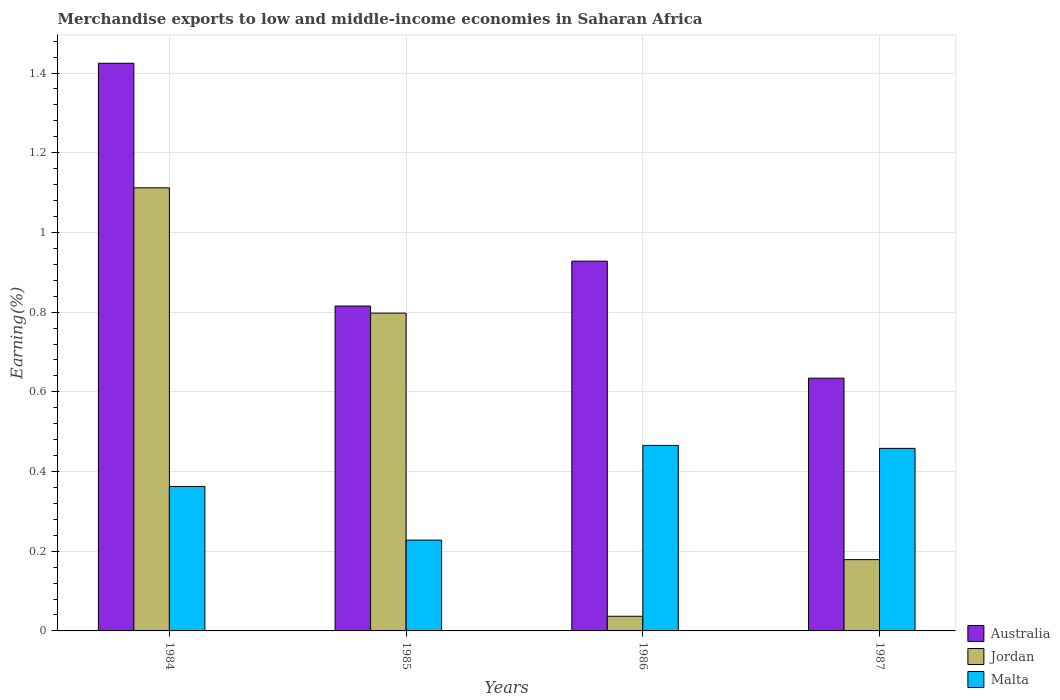How many different coloured bars are there?
Give a very brief answer. 3. How many groups of bars are there?
Your answer should be compact. 4. Are the number of bars per tick equal to the number of legend labels?
Ensure brevity in your answer.  Yes. How many bars are there on the 1st tick from the right?
Ensure brevity in your answer.  3. In how many cases, is the number of bars for a given year not equal to the number of legend labels?
Your response must be concise. 0. What is the percentage of amount earned from merchandise exports in Jordan in 1987?
Your answer should be compact. 0.18. Across all years, what is the maximum percentage of amount earned from merchandise exports in Malta?
Provide a succinct answer. 0.47. Across all years, what is the minimum percentage of amount earned from merchandise exports in Australia?
Your answer should be compact. 0.63. In which year was the percentage of amount earned from merchandise exports in Malta minimum?
Give a very brief answer. 1985. What is the total percentage of amount earned from merchandise exports in Australia in the graph?
Your response must be concise. 3.8. What is the difference between the percentage of amount earned from merchandise exports in Australia in 1986 and that in 1987?
Ensure brevity in your answer.  0.29. What is the difference between the percentage of amount earned from merchandise exports in Australia in 1986 and the percentage of amount earned from merchandise exports in Jordan in 1984?
Your answer should be compact. -0.18. What is the average percentage of amount earned from merchandise exports in Malta per year?
Your answer should be very brief. 0.38. In the year 1986, what is the difference between the percentage of amount earned from merchandise exports in Malta and percentage of amount earned from merchandise exports in Australia?
Provide a succinct answer. -0.46. What is the ratio of the percentage of amount earned from merchandise exports in Malta in 1984 to that in 1987?
Offer a terse response. 0.79. What is the difference between the highest and the second highest percentage of amount earned from merchandise exports in Malta?
Give a very brief answer. 0.01. What is the difference between the highest and the lowest percentage of amount earned from merchandise exports in Jordan?
Provide a succinct answer. 1.08. What does the 2nd bar from the right in 1987 represents?
Give a very brief answer. Jordan. What is the difference between two consecutive major ticks on the Y-axis?
Your response must be concise. 0.2. Does the graph contain any zero values?
Provide a succinct answer. No. Does the graph contain grids?
Your response must be concise. Yes. What is the title of the graph?
Your answer should be very brief. Merchandise exports to low and middle-income economies in Saharan Africa. What is the label or title of the X-axis?
Ensure brevity in your answer.  Years. What is the label or title of the Y-axis?
Offer a very short reply. Earning(%). What is the Earning(%) of Australia in 1984?
Offer a very short reply. 1.42. What is the Earning(%) in Jordan in 1984?
Provide a succinct answer. 1.11. What is the Earning(%) of Malta in 1984?
Ensure brevity in your answer.  0.36. What is the Earning(%) in Australia in 1985?
Your response must be concise. 0.82. What is the Earning(%) of Jordan in 1985?
Keep it short and to the point. 0.8. What is the Earning(%) of Malta in 1985?
Your answer should be very brief. 0.23. What is the Earning(%) in Australia in 1986?
Your response must be concise. 0.93. What is the Earning(%) in Jordan in 1986?
Your response must be concise. 0.04. What is the Earning(%) of Malta in 1986?
Your response must be concise. 0.47. What is the Earning(%) of Australia in 1987?
Offer a terse response. 0.63. What is the Earning(%) of Jordan in 1987?
Your answer should be compact. 0.18. What is the Earning(%) of Malta in 1987?
Give a very brief answer. 0.46. Across all years, what is the maximum Earning(%) of Australia?
Your answer should be very brief. 1.42. Across all years, what is the maximum Earning(%) of Jordan?
Provide a short and direct response. 1.11. Across all years, what is the maximum Earning(%) of Malta?
Give a very brief answer. 0.47. Across all years, what is the minimum Earning(%) of Australia?
Ensure brevity in your answer.  0.63. Across all years, what is the minimum Earning(%) of Jordan?
Your answer should be compact. 0.04. Across all years, what is the minimum Earning(%) of Malta?
Give a very brief answer. 0.23. What is the total Earning(%) in Australia in the graph?
Offer a terse response. 3.8. What is the total Earning(%) of Jordan in the graph?
Make the answer very short. 2.13. What is the total Earning(%) of Malta in the graph?
Make the answer very short. 1.51. What is the difference between the Earning(%) in Australia in 1984 and that in 1985?
Your response must be concise. 0.61. What is the difference between the Earning(%) of Jordan in 1984 and that in 1985?
Your answer should be compact. 0.31. What is the difference between the Earning(%) in Malta in 1984 and that in 1985?
Your answer should be compact. 0.13. What is the difference between the Earning(%) of Australia in 1984 and that in 1986?
Your answer should be compact. 0.5. What is the difference between the Earning(%) of Jordan in 1984 and that in 1986?
Your answer should be compact. 1.08. What is the difference between the Earning(%) of Malta in 1984 and that in 1986?
Give a very brief answer. -0.1. What is the difference between the Earning(%) in Australia in 1984 and that in 1987?
Your answer should be compact. 0.79. What is the difference between the Earning(%) of Jordan in 1984 and that in 1987?
Provide a short and direct response. 0.93. What is the difference between the Earning(%) in Malta in 1984 and that in 1987?
Keep it short and to the point. -0.1. What is the difference between the Earning(%) of Australia in 1985 and that in 1986?
Your answer should be compact. -0.11. What is the difference between the Earning(%) of Jordan in 1985 and that in 1986?
Make the answer very short. 0.76. What is the difference between the Earning(%) of Malta in 1985 and that in 1986?
Make the answer very short. -0.24. What is the difference between the Earning(%) of Australia in 1985 and that in 1987?
Your response must be concise. 0.18. What is the difference between the Earning(%) of Jordan in 1985 and that in 1987?
Give a very brief answer. 0.62. What is the difference between the Earning(%) in Malta in 1985 and that in 1987?
Ensure brevity in your answer.  -0.23. What is the difference between the Earning(%) of Australia in 1986 and that in 1987?
Provide a succinct answer. 0.29. What is the difference between the Earning(%) of Jordan in 1986 and that in 1987?
Your answer should be compact. -0.14. What is the difference between the Earning(%) in Malta in 1986 and that in 1987?
Your answer should be very brief. 0.01. What is the difference between the Earning(%) of Australia in 1984 and the Earning(%) of Jordan in 1985?
Your answer should be very brief. 0.63. What is the difference between the Earning(%) in Australia in 1984 and the Earning(%) in Malta in 1985?
Your answer should be very brief. 1.2. What is the difference between the Earning(%) of Jordan in 1984 and the Earning(%) of Malta in 1985?
Give a very brief answer. 0.88. What is the difference between the Earning(%) of Australia in 1984 and the Earning(%) of Jordan in 1986?
Your answer should be very brief. 1.39. What is the difference between the Earning(%) in Jordan in 1984 and the Earning(%) in Malta in 1986?
Give a very brief answer. 0.65. What is the difference between the Earning(%) of Australia in 1984 and the Earning(%) of Jordan in 1987?
Your response must be concise. 1.25. What is the difference between the Earning(%) of Australia in 1984 and the Earning(%) of Malta in 1987?
Make the answer very short. 0.97. What is the difference between the Earning(%) of Jordan in 1984 and the Earning(%) of Malta in 1987?
Offer a terse response. 0.65. What is the difference between the Earning(%) in Australia in 1985 and the Earning(%) in Jordan in 1986?
Offer a very short reply. 0.78. What is the difference between the Earning(%) in Australia in 1985 and the Earning(%) in Malta in 1986?
Provide a succinct answer. 0.35. What is the difference between the Earning(%) in Jordan in 1985 and the Earning(%) in Malta in 1986?
Your answer should be very brief. 0.33. What is the difference between the Earning(%) in Australia in 1985 and the Earning(%) in Jordan in 1987?
Make the answer very short. 0.64. What is the difference between the Earning(%) of Australia in 1985 and the Earning(%) of Malta in 1987?
Your response must be concise. 0.36. What is the difference between the Earning(%) in Jordan in 1985 and the Earning(%) in Malta in 1987?
Offer a very short reply. 0.34. What is the difference between the Earning(%) of Australia in 1986 and the Earning(%) of Jordan in 1987?
Give a very brief answer. 0.75. What is the difference between the Earning(%) in Australia in 1986 and the Earning(%) in Malta in 1987?
Provide a short and direct response. 0.47. What is the difference between the Earning(%) in Jordan in 1986 and the Earning(%) in Malta in 1987?
Offer a terse response. -0.42. What is the average Earning(%) of Australia per year?
Ensure brevity in your answer.  0.95. What is the average Earning(%) of Jordan per year?
Your answer should be very brief. 0.53. What is the average Earning(%) in Malta per year?
Make the answer very short. 0.38. In the year 1984, what is the difference between the Earning(%) of Australia and Earning(%) of Jordan?
Your answer should be very brief. 0.31. In the year 1984, what is the difference between the Earning(%) in Australia and Earning(%) in Malta?
Give a very brief answer. 1.06. In the year 1984, what is the difference between the Earning(%) of Jordan and Earning(%) of Malta?
Make the answer very short. 0.75. In the year 1985, what is the difference between the Earning(%) of Australia and Earning(%) of Jordan?
Offer a terse response. 0.02. In the year 1985, what is the difference between the Earning(%) of Australia and Earning(%) of Malta?
Offer a very short reply. 0.59. In the year 1985, what is the difference between the Earning(%) in Jordan and Earning(%) in Malta?
Your response must be concise. 0.57. In the year 1986, what is the difference between the Earning(%) of Australia and Earning(%) of Jordan?
Provide a short and direct response. 0.89. In the year 1986, what is the difference between the Earning(%) in Australia and Earning(%) in Malta?
Offer a very short reply. 0.46. In the year 1986, what is the difference between the Earning(%) in Jordan and Earning(%) in Malta?
Keep it short and to the point. -0.43. In the year 1987, what is the difference between the Earning(%) of Australia and Earning(%) of Jordan?
Make the answer very short. 0.46. In the year 1987, what is the difference between the Earning(%) in Australia and Earning(%) in Malta?
Your answer should be very brief. 0.18. In the year 1987, what is the difference between the Earning(%) of Jordan and Earning(%) of Malta?
Your answer should be compact. -0.28. What is the ratio of the Earning(%) of Australia in 1984 to that in 1985?
Your answer should be very brief. 1.75. What is the ratio of the Earning(%) in Jordan in 1984 to that in 1985?
Ensure brevity in your answer.  1.39. What is the ratio of the Earning(%) of Malta in 1984 to that in 1985?
Offer a terse response. 1.59. What is the ratio of the Earning(%) of Australia in 1984 to that in 1986?
Your answer should be very brief. 1.54. What is the ratio of the Earning(%) of Jordan in 1984 to that in 1986?
Provide a short and direct response. 30.24. What is the ratio of the Earning(%) of Malta in 1984 to that in 1986?
Your response must be concise. 0.78. What is the ratio of the Earning(%) in Australia in 1984 to that in 1987?
Provide a short and direct response. 2.25. What is the ratio of the Earning(%) in Jordan in 1984 to that in 1987?
Provide a short and direct response. 6.22. What is the ratio of the Earning(%) in Malta in 1984 to that in 1987?
Make the answer very short. 0.79. What is the ratio of the Earning(%) in Australia in 1985 to that in 1986?
Your answer should be very brief. 0.88. What is the ratio of the Earning(%) in Jordan in 1985 to that in 1986?
Your answer should be compact. 21.69. What is the ratio of the Earning(%) of Malta in 1985 to that in 1986?
Provide a succinct answer. 0.49. What is the ratio of the Earning(%) in Australia in 1985 to that in 1987?
Your response must be concise. 1.29. What is the ratio of the Earning(%) of Jordan in 1985 to that in 1987?
Provide a succinct answer. 4.46. What is the ratio of the Earning(%) in Malta in 1985 to that in 1987?
Your answer should be compact. 0.5. What is the ratio of the Earning(%) in Australia in 1986 to that in 1987?
Offer a very short reply. 1.46. What is the ratio of the Earning(%) in Jordan in 1986 to that in 1987?
Offer a very short reply. 0.21. What is the ratio of the Earning(%) of Malta in 1986 to that in 1987?
Make the answer very short. 1.02. What is the difference between the highest and the second highest Earning(%) of Australia?
Your answer should be compact. 0.5. What is the difference between the highest and the second highest Earning(%) of Jordan?
Offer a terse response. 0.31. What is the difference between the highest and the second highest Earning(%) of Malta?
Your answer should be very brief. 0.01. What is the difference between the highest and the lowest Earning(%) in Australia?
Provide a short and direct response. 0.79. What is the difference between the highest and the lowest Earning(%) in Jordan?
Offer a terse response. 1.08. What is the difference between the highest and the lowest Earning(%) of Malta?
Your response must be concise. 0.24. 